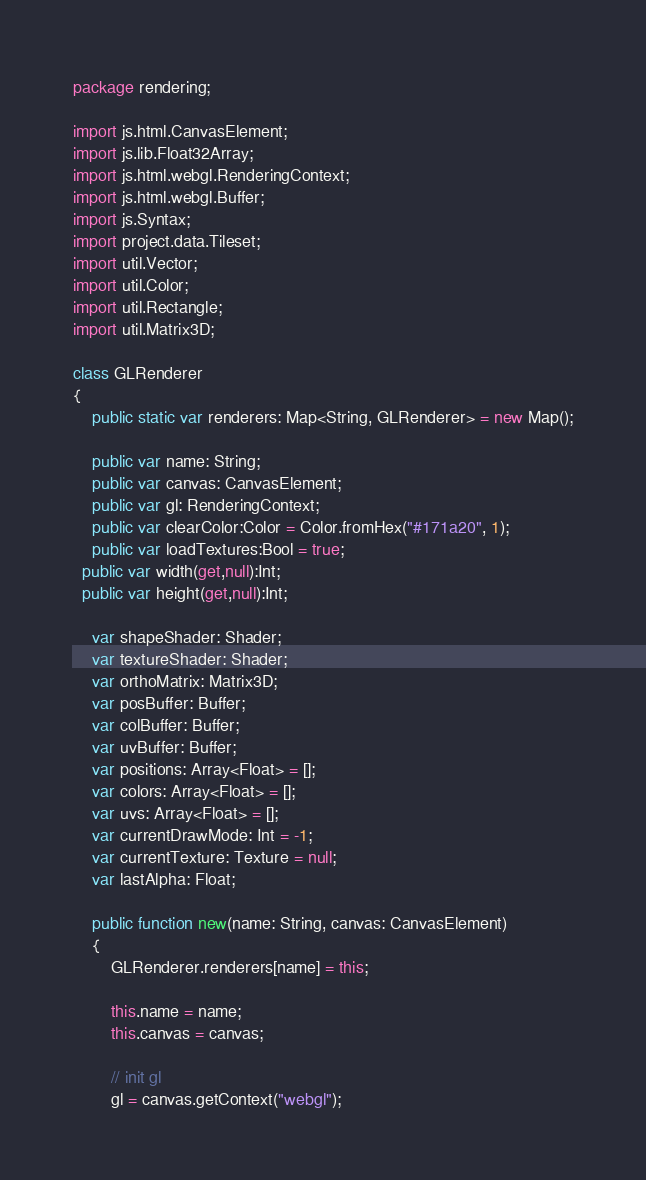Convert code to text. <code><loc_0><loc_0><loc_500><loc_500><_Haxe_>package rendering;

import js.html.CanvasElement;
import js.lib.Float32Array;
import js.html.webgl.RenderingContext;
import js.html.webgl.Buffer;
import js.Syntax;
import project.data.Tileset;
import util.Vector;
import util.Color;
import util.Rectangle;
import util.Matrix3D;

class GLRenderer
{
	public static var renderers: Map<String, GLRenderer> = new Map();
	
	public var name: String;
	public var canvas: CanvasElement;
	public var gl: RenderingContext; 
	public var clearColor:Color = Color.fromHex("#171a20", 1);
	public var loadTextures:Bool = true;
  public var width(get,null):Int;
  public var height(get,null):Int;
	
	var shapeShader: Shader;
	var textureShader: Shader;
	var orthoMatrix: Matrix3D;
	var posBuffer: Buffer;
	var colBuffer: Buffer;  
	var uvBuffer: Buffer; 
	var positions: Array<Float> = [];
	var colors: Array<Float> = [];
	var uvs: Array<Float> = [];
	var currentDrawMode: Int = -1;
	var currentTexture: Texture = null;
	var lastAlpha: Float;
	
	public function new(name: String, canvas: CanvasElement)
	{
		GLRenderer.renderers[name] = this;
		
		this.name = name;
		this.canvas = canvas;
		
		// init gl
		gl = canvas.getContext("webgl");</code> 